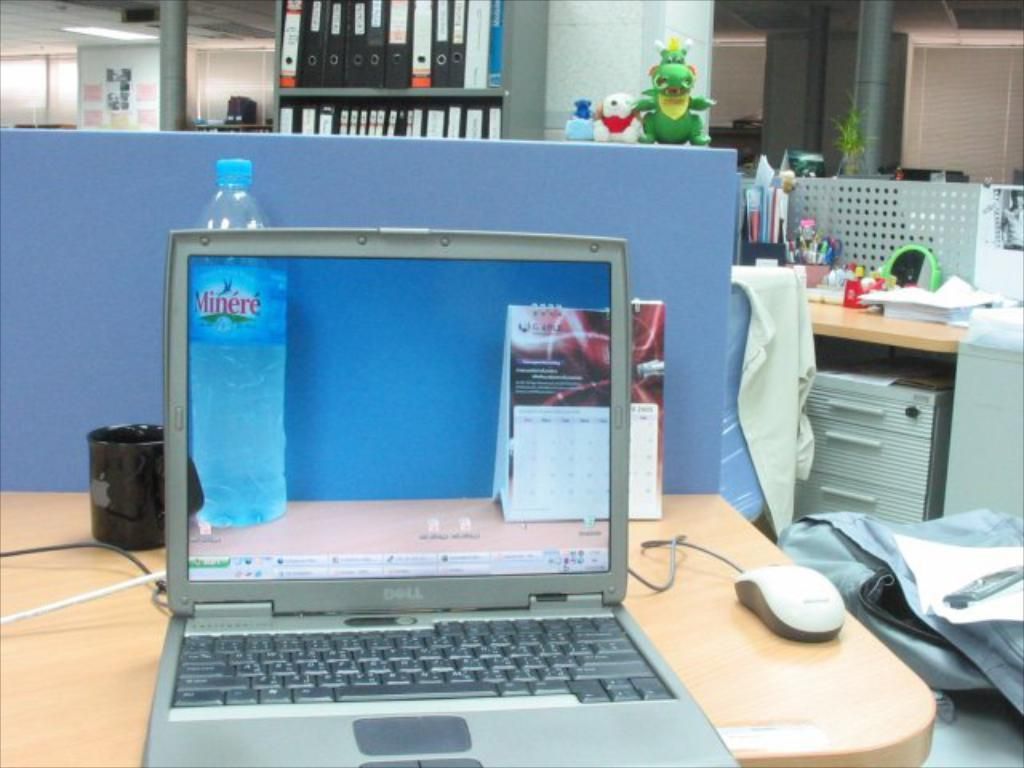Provide a one-sentence caption for the provided image. A laptop screen shows a bottle of Minere water. 